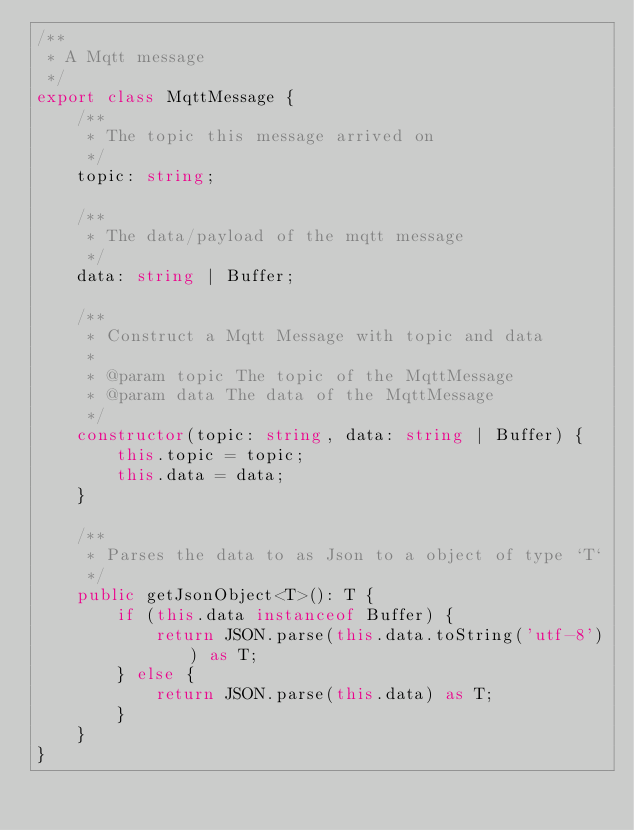Convert code to text. <code><loc_0><loc_0><loc_500><loc_500><_TypeScript_>/**
 * A Mqtt message 
 */
export class MqttMessage {
    /**
     * The topic this message arrived on
     */
    topic: string;

    /**
     * The data/payload of the mqtt message
     */
    data: string | Buffer;

    /**
     * Construct a Mqtt Message with topic and data
     * 
     * @param topic The topic of the MqttMessage
     * @param data The data of the MqttMessage
     */
    constructor(topic: string, data: string | Buffer) {
        this.topic = topic;
        this.data = data;
    }

    /**
     * Parses the data to as Json to a object of type `T`
     */
    public getJsonObject<T>(): T {
        if (this.data instanceof Buffer) {
            return JSON.parse(this.data.toString('utf-8')) as T;
        } else {
            return JSON.parse(this.data) as T;
        }
    }
}</code> 